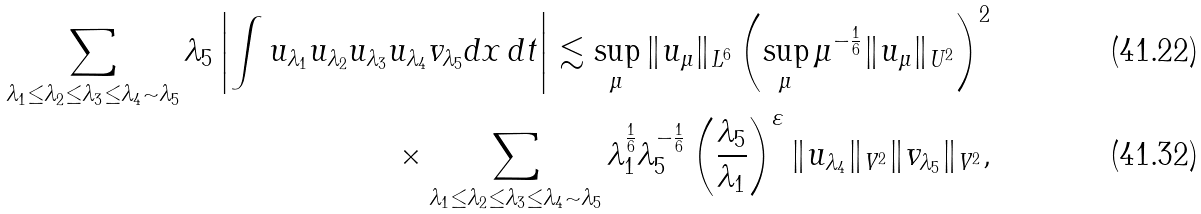Convert formula to latex. <formula><loc_0><loc_0><loc_500><loc_500>\sum _ { \lambda _ { 1 } \leq \lambda _ { 2 } \leq \lambda _ { 3 } \leq \lambda _ { 4 } \sim \lambda _ { 5 } } \lambda _ { 5 } \left | \int u _ { \lambda _ { 1 } } u _ { \lambda _ { 2 } } u _ { \lambda _ { 3 } } u _ { \lambda _ { 4 } } v _ { \lambda _ { 5 } } d x \, d t \right | \lesssim \sup _ { \mu } \| u _ { \mu } \| _ { L ^ { 6 } } \left ( \sup _ { \mu } \mu ^ { - \frac { 1 } { 6 } } \| u _ { \mu } \| _ { U ^ { 2 } } \right ) ^ { 2 } \\ \times \sum _ { \lambda _ { 1 } \leq \lambda _ { 2 } \leq \lambda _ { 3 } \leq \lambda _ { 4 } \sim \lambda _ { 5 } } \lambda _ { 1 } ^ { \frac { 1 } { 6 } } \lambda _ { 5 } ^ { - \frac { 1 } { 6 } } \left ( \frac { \lambda _ { 5 } } { \lambda _ { 1 } } \right ) ^ { \varepsilon } \| u _ { \lambda _ { 4 } } \| _ { V ^ { 2 } } \| v _ { \lambda _ { 5 } } \| _ { V ^ { 2 } } ,</formula> 